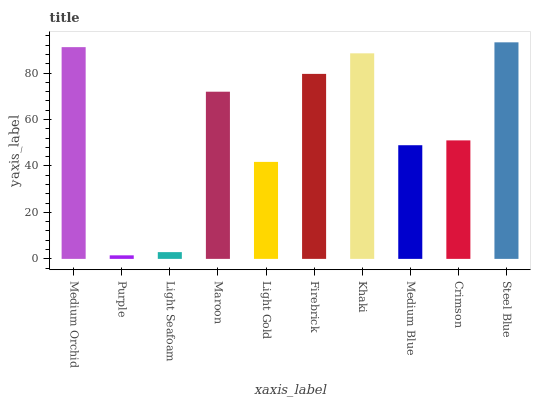Is Light Seafoam the minimum?
Answer yes or no. No. Is Light Seafoam the maximum?
Answer yes or no. No. Is Light Seafoam greater than Purple?
Answer yes or no. Yes. Is Purple less than Light Seafoam?
Answer yes or no. Yes. Is Purple greater than Light Seafoam?
Answer yes or no. No. Is Light Seafoam less than Purple?
Answer yes or no. No. Is Maroon the high median?
Answer yes or no. Yes. Is Crimson the low median?
Answer yes or no. Yes. Is Firebrick the high median?
Answer yes or no. No. Is Firebrick the low median?
Answer yes or no. No. 